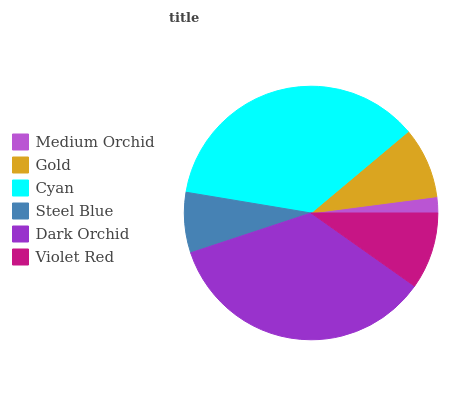Is Medium Orchid the minimum?
Answer yes or no. Yes. Is Cyan the maximum?
Answer yes or no. Yes. Is Gold the minimum?
Answer yes or no. No. Is Gold the maximum?
Answer yes or no. No. Is Gold greater than Medium Orchid?
Answer yes or no. Yes. Is Medium Orchid less than Gold?
Answer yes or no. Yes. Is Medium Orchid greater than Gold?
Answer yes or no. No. Is Gold less than Medium Orchid?
Answer yes or no. No. Is Violet Red the high median?
Answer yes or no. Yes. Is Gold the low median?
Answer yes or no. Yes. Is Gold the high median?
Answer yes or no. No. Is Cyan the low median?
Answer yes or no. No. 